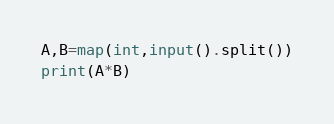<code> <loc_0><loc_0><loc_500><loc_500><_Python_>A,B=map(int,input().split())
print(A*B)</code> 